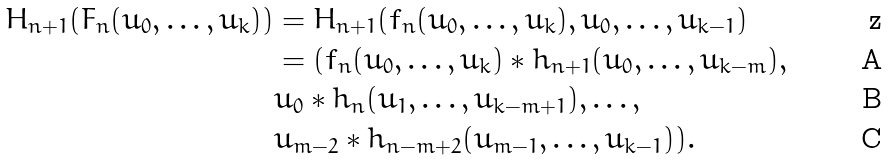Convert formula to latex. <formula><loc_0><loc_0><loc_500><loc_500>H _ { n + 1 } ( F _ { n } ( u _ { 0 } , \dots , u _ { k } ) ) & = H _ { n + 1 } ( f _ { n } ( u _ { 0 } , \dots , u _ { k } ) , u _ { 0 } , \dots , u _ { k - 1 } ) \\ & = ( f _ { n } ( u _ { 0 } , \dots , u _ { k } ) \ast h _ { n + 1 } ( u _ { 0 } , \dots , u _ { k - m } ) , \\ & u _ { 0 } \ast h _ { n } ( u _ { 1 } , \dots , u _ { k - m + 1 } ) , \dots , \\ & u _ { m - 2 } \ast h _ { n - m + 2 } ( u _ { m - 1 } , \dots , u _ { k - 1 } ) ) .</formula> 